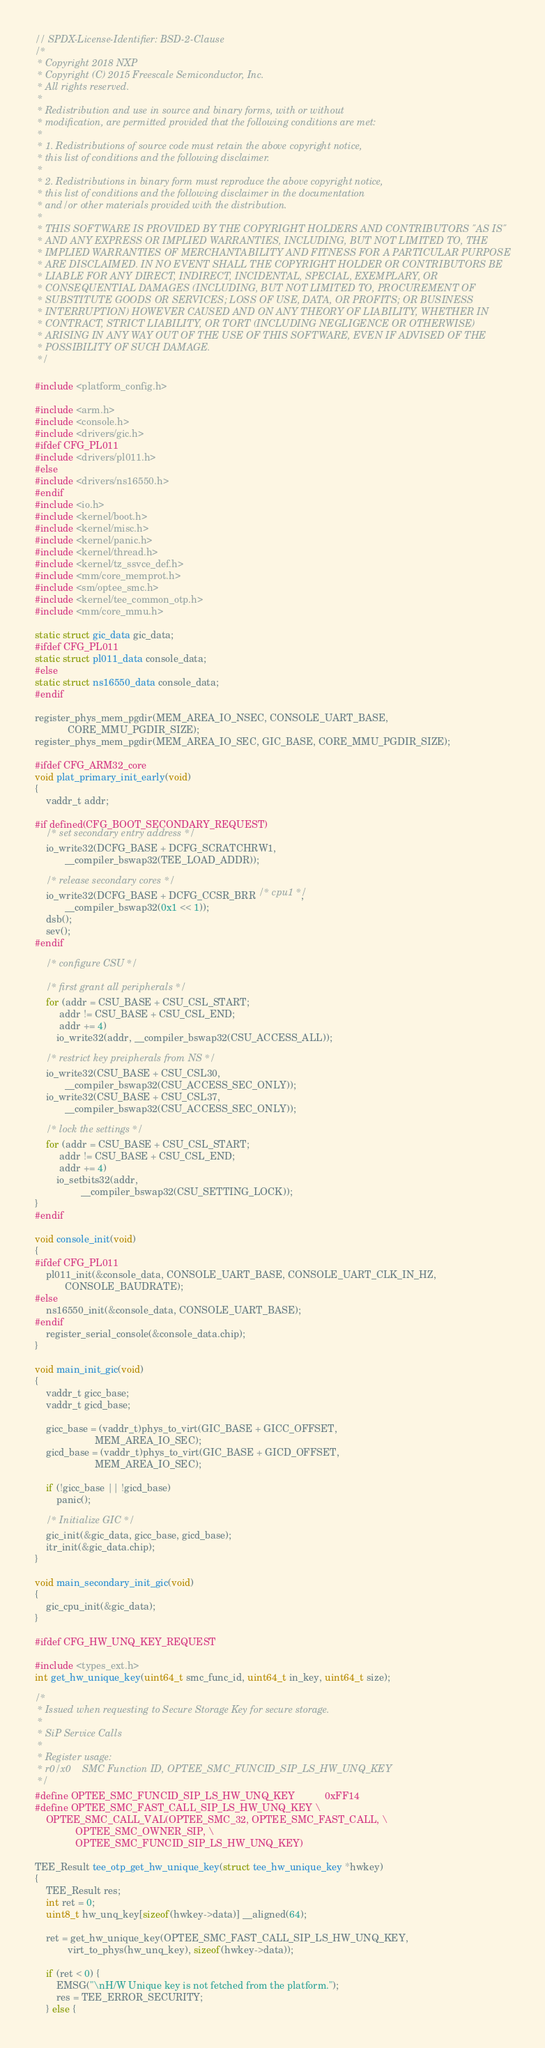<code> <loc_0><loc_0><loc_500><loc_500><_C_>// SPDX-License-Identifier: BSD-2-Clause
/*
 * Copyright 2018 NXP
 * Copyright (C) 2015 Freescale Semiconductor, Inc.
 * All rights reserved.
 *
 * Redistribution and use in source and binary forms, with or without
 * modification, are permitted provided that the following conditions are met:
 *
 * 1. Redistributions of source code must retain the above copyright notice,
 * this list of conditions and the following disclaimer.
 *
 * 2. Redistributions in binary form must reproduce the above copyright notice,
 * this list of conditions and the following disclaimer in the documentation
 * and/or other materials provided with the distribution.
 *
 * THIS SOFTWARE IS PROVIDED BY THE COPYRIGHT HOLDERS AND CONTRIBUTORS "AS IS"
 * AND ANY EXPRESS OR IMPLIED WARRANTIES, INCLUDING, BUT NOT LIMITED TO, THE
 * IMPLIED WARRANTIES OF MERCHANTABILITY AND FITNESS FOR A PARTICULAR PURPOSE
 * ARE DISCLAIMED. IN NO EVENT SHALL THE COPYRIGHT HOLDER OR CONTRIBUTORS BE
 * LIABLE FOR ANY DIRECT, INDIRECT, INCIDENTAL, SPECIAL, EXEMPLARY, OR
 * CONSEQUENTIAL DAMAGES (INCLUDING, BUT NOT LIMITED TO, PROCUREMENT OF
 * SUBSTITUTE GOODS OR SERVICES; LOSS OF USE, DATA, OR PROFITS; OR BUSINESS
 * INTERRUPTION) HOWEVER CAUSED AND ON ANY THEORY OF LIABILITY, WHETHER IN
 * CONTRACT, STRICT LIABILITY, OR TORT (INCLUDING NEGLIGENCE OR OTHERWISE)
 * ARISING IN ANY WAY OUT OF THE USE OF THIS SOFTWARE, EVEN IF ADVISED OF THE
 * POSSIBILITY OF SUCH DAMAGE.
 */

#include <platform_config.h>

#include <arm.h>
#include <console.h>
#include <drivers/gic.h>
#ifdef CFG_PL011
#include <drivers/pl011.h>
#else
#include <drivers/ns16550.h>
#endif
#include <io.h>
#include <kernel/boot.h>
#include <kernel/misc.h>
#include <kernel/panic.h>
#include <kernel/thread.h>
#include <kernel/tz_ssvce_def.h>
#include <mm/core_memprot.h>
#include <sm/optee_smc.h>
#include <kernel/tee_common_otp.h>
#include <mm/core_mmu.h>

static struct gic_data gic_data;
#ifdef CFG_PL011
static struct pl011_data console_data;
#else
static struct ns16550_data console_data;
#endif

register_phys_mem_pgdir(MEM_AREA_IO_NSEC, CONSOLE_UART_BASE,
			CORE_MMU_PGDIR_SIZE);
register_phys_mem_pgdir(MEM_AREA_IO_SEC, GIC_BASE, CORE_MMU_PGDIR_SIZE);

#ifdef CFG_ARM32_core
void plat_primary_init_early(void)
{
	vaddr_t addr;

#if defined(CFG_BOOT_SECONDARY_REQUEST)
	/* set secondary entry address */
	io_write32(DCFG_BASE + DCFG_SCRATCHRW1,
		   __compiler_bswap32(TEE_LOAD_ADDR));

	/* release secondary cores */
	io_write32(DCFG_BASE + DCFG_CCSR_BRR /* cpu1 */,
		   __compiler_bswap32(0x1 << 1));
	dsb();
	sev();
#endif

	/* configure CSU */

	/* first grant all peripherals */
	for (addr = CSU_BASE + CSU_CSL_START;
		 addr != CSU_BASE + CSU_CSL_END;
		 addr += 4)
		io_write32(addr, __compiler_bswap32(CSU_ACCESS_ALL));

	/* restrict key preipherals from NS */
	io_write32(CSU_BASE + CSU_CSL30,
		   __compiler_bswap32(CSU_ACCESS_SEC_ONLY));
	io_write32(CSU_BASE + CSU_CSL37,
		   __compiler_bswap32(CSU_ACCESS_SEC_ONLY));

	/* lock the settings */
	for (addr = CSU_BASE + CSU_CSL_START;
	     addr != CSU_BASE + CSU_CSL_END;
	     addr += 4)
		io_setbits32(addr,
			     __compiler_bswap32(CSU_SETTING_LOCK));
}
#endif

void console_init(void)
{
#ifdef CFG_PL011
	pl011_init(&console_data, CONSOLE_UART_BASE, CONSOLE_UART_CLK_IN_HZ,
		   CONSOLE_BAUDRATE);
#else
	ns16550_init(&console_data, CONSOLE_UART_BASE);
#endif
	register_serial_console(&console_data.chip);
}

void main_init_gic(void)
{
	vaddr_t gicc_base;
	vaddr_t gicd_base;

	gicc_base = (vaddr_t)phys_to_virt(GIC_BASE + GICC_OFFSET,
					  MEM_AREA_IO_SEC);
	gicd_base = (vaddr_t)phys_to_virt(GIC_BASE + GICD_OFFSET,
					  MEM_AREA_IO_SEC);

	if (!gicc_base || !gicd_base)
		panic();

	/* Initialize GIC */
	gic_init(&gic_data, gicc_base, gicd_base);
	itr_init(&gic_data.chip);
}

void main_secondary_init_gic(void)
{
	gic_cpu_init(&gic_data);
}

#ifdef CFG_HW_UNQ_KEY_REQUEST

#include <types_ext.h>
int get_hw_unique_key(uint64_t smc_func_id, uint64_t in_key, uint64_t size);

/*
 * Issued when requesting to Secure Storage Key for secure storage.
 *
 * SiP Service Calls
 *
 * Register usage:
 * r0/x0	SMC Function ID, OPTEE_SMC_FUNCID_SIP_LS_HW_UNQ_KEY
 */
#define OPTEE_SMC_FUNCID_SIP_LS_HW_UNQ_KEY			0xFF14
#define OPTEE_SMC_FAST_CALL_SIP_LS_HW_UNQ_KEY \
	OPTEE_SMC_CALL_VAL(OPTEE_SMC_32, OPTEE_SMC_FAST_CALL, \
			   OPTEE_SMC_OWNER_SIP, \
			   OPTEE_SMC_FUNCID_SIP_LS_HW_UNQ_KEY)

TEE_Result tee_otp_get_hw_unique_key(struct tee_hw_unique_key *hwkey)
{
	TEE_Result res;
	int ret = 0;
	uint8_t hw_unq_key[sizeof(hwkey->data)] __aligned(64);

	ret = get_hw_unique_key(OPTEE_SMC_FAST_CALL_SIP_LS_HW_UNQ_KEY,
			virt_to_phys(hw_unq_key), sizeof(hwkey->data));

	if (ret < 0) {
		EMSG("\nH/W Unique key is not fetched from the platform.");
		res = TEE_ERROR_SECURITY;
	} else {</code> 